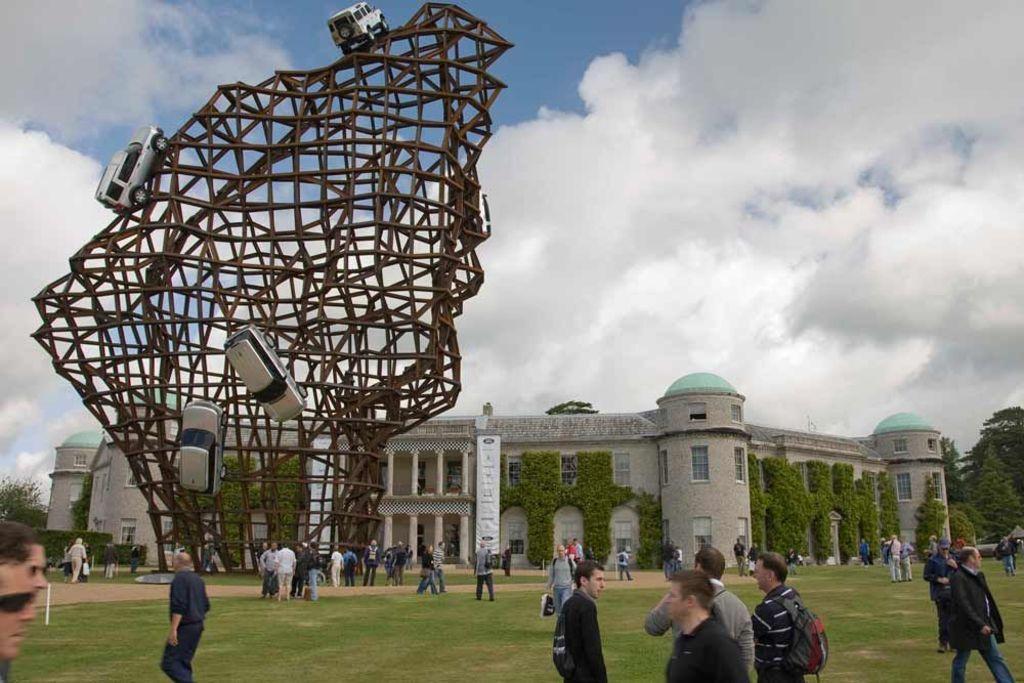In one or two sentences, can you explain what this image depicts? In the picture I can see a building, people standing on the ground, the grass, trees, plants, a banner and some other objects on the ground. In the background I can see the sky and statues in the shape of vehicle. 